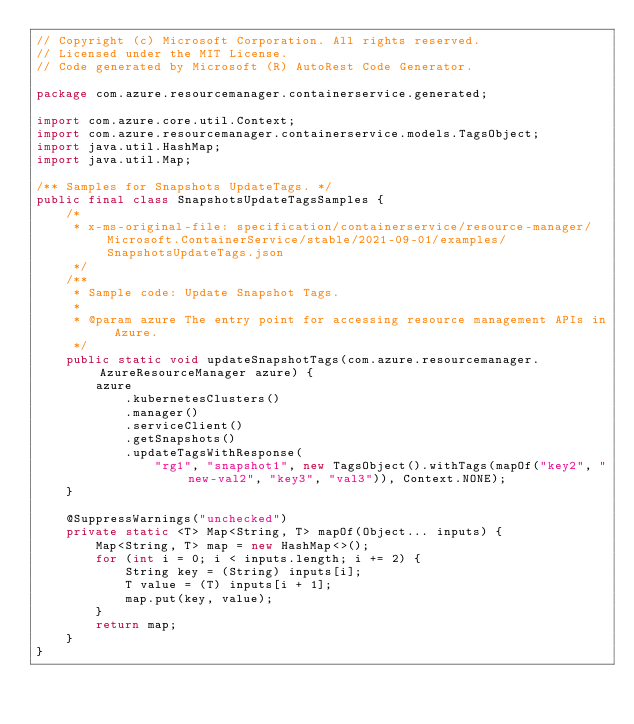Convert code to text. <code><loc_0><loc_0><loc_500><loc_500><_Java_>// Copyright (c) Microsoft Corporation. All rights reserved.
// Licensed under the MIT License.
// Code generated by Microsoft (R) AutoRest Code Generator.

package com.azure.resourcemanager.containerservice.generated;

import com.azure.core.util.Context;
import com.azure.resourcemanager.containerservice.models.TagsObject;
import java.util.HashMap;
import java.util.Map;

/** Samples for Snapshots UpdateTags. */
public final class SnapshotsUpdateTagsSamples {
    /*
     * x-ms-original-file: specification/containerservice/resource-manager/Microsoft.ContainerService/stable/2021-09-01/examples/SnapshotsUpdateTags.json
     */
    /**
     * Sample code: Update Snapshot Tags.
     *
     * @param azure The entry point for accessing resource management APIs in Azure.
     */
    public static void updateSnapshotTags(com.azure.resourcemanager.AzureResourceManager azure) {
        azure
            .kubernetesClusters()
            .manager()
            .serviceClient()
            .getSnapshots()
            .updateTagsWithResponse(
                "rg1", "snapshot1", new TagsObject().withTags(mapOf("key2", "new-val2", "key3", "val3")), Context.NONE);
    }

    @SuppressWarnings("unchecked")
    private static <T> Map<String, T> mapOf(Object... inputs) {
        Map<String, T> map = new HashMap<>();
        for (int i = 0; i < inputs.length; i += 2) {
            String key = (String) inputs[i];
            T value = (T) inputs[i + 1];
            map.put(key, value);
        }
        return map;
    }
}
</code> 